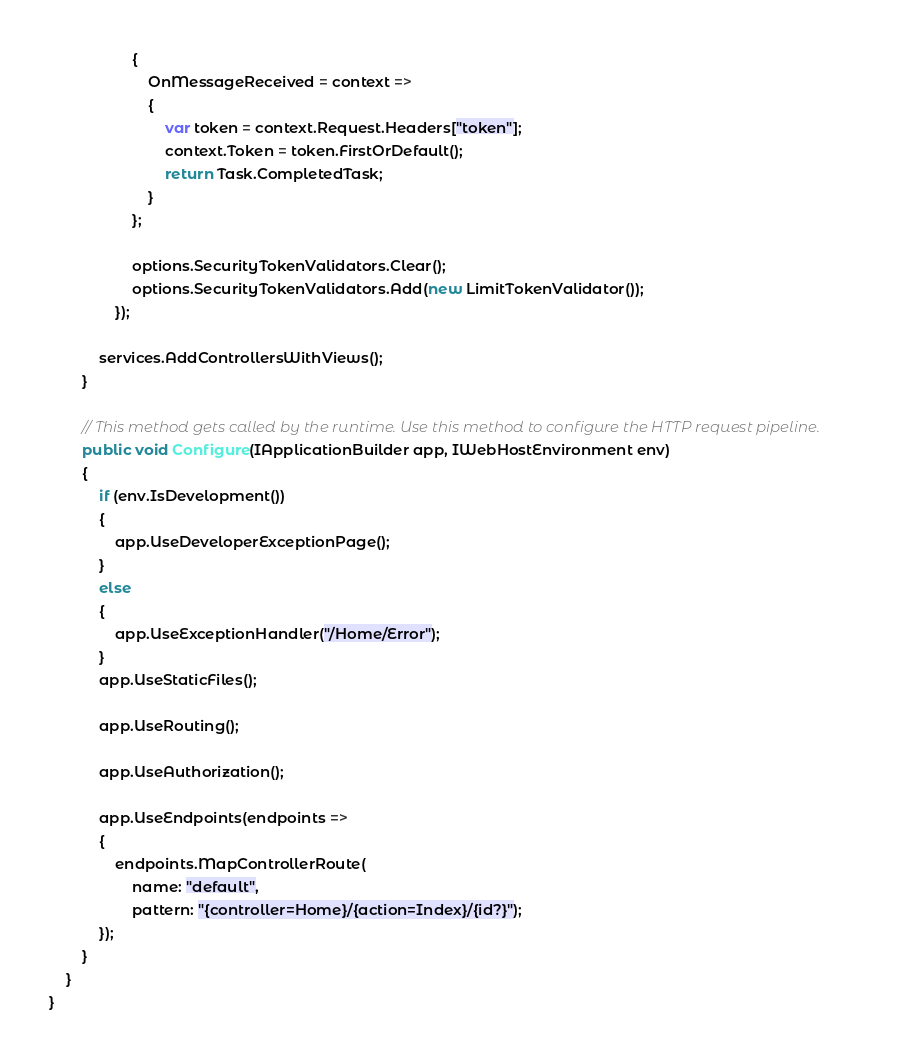<code> <loc_0><loc_0><loc_500><loc_500><_C#_>                    {
                        OnMessageReceived = context =>
                        {
                            var token = context.Request.Headers["token"];
                            context.Token = token.FirstOrDefault();
                            return Task.CompletedTask;
                        }
                    };

                    options.SecurityTokenValidators.Clear();
                    options.SecurityTokenValidators.Add(new LimitTokenValidator());
                });

            services.AddControllersWithViews();
        }

        // This method gets called by the runtime. Use this method to configure the HTTP request pipeline.
        public void Configure(IApplicationBuilder app, IWebHostEnvironment env)
        {
            if (env.IsDevelopment())
            {
                app.UseDeveloperExceptionPage();
            }
            else
            {
                app.UseExceptionHandler("/Home/Error");
            }
            app.UseStaticFiles();

            app.UseRouting();

            app.UseAuthorization();

            app.UseEndpoints(endpoints =>
            {
                endpoints.MapControllerRoute(
                    name: "default",
                    pattern: "{controller=Home}/{action=Index}/{id?}");
            });
        }
    }
}
</code> 